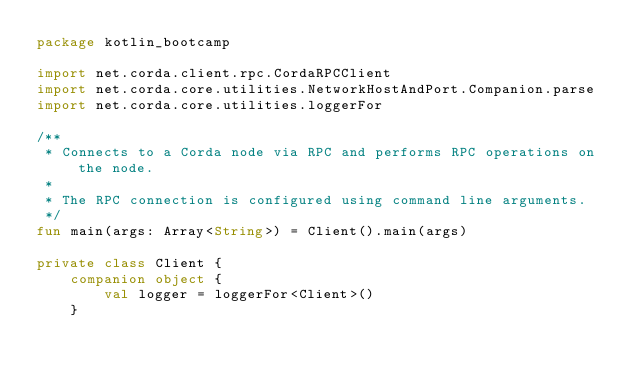Convert code to text. <code><loc_0><loc_0><loc_500><loc_500><_Kotlin_>package kotlin_bootcamp

import net.corda.client.rpc.CordaRPCClient
import net.corda.core.utilities.NetworkHostAndPort.Companion.parse
import net.corda.core.utilities.loggerFor

/**
 * Connects to a Corda node via RPC and performs RPC operations on the node.
 *
 * The RPC connection is configured using command line arguments.
 */
fun main(args: Array<String>) = Client().main(args)

private class Client {
    companion object {
        val logger = loggerFor<Client>()
    }
</code> 